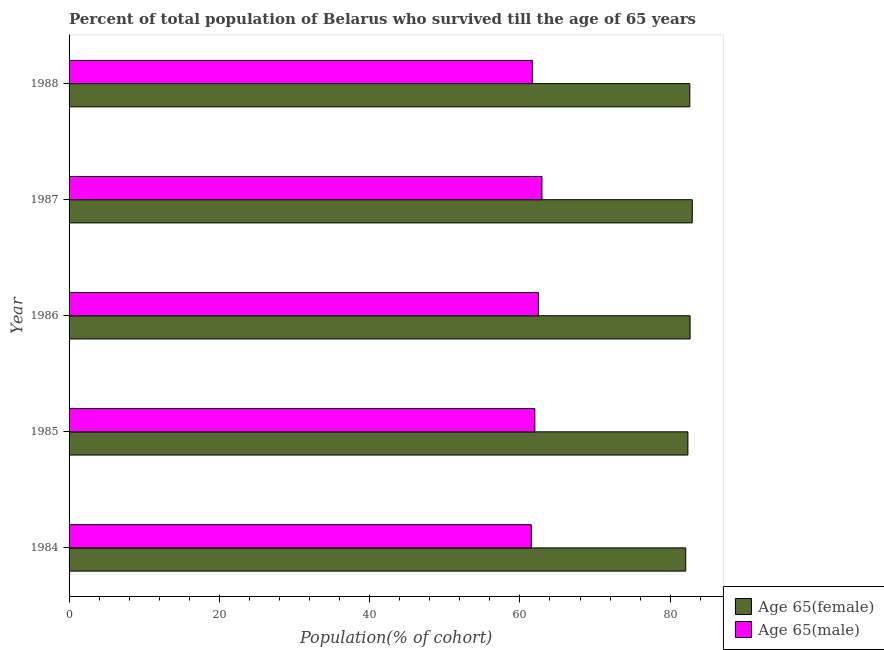How many different coloured bars are there?
Your response must be concise. 2. What is the label of the 4th group of bars from the top?
Ensure brevity in your answer.  1985. In how many cases, is the number of bars for a given year not equal to the number of legend labels?
Your answer should be compact. 0. What is the percentage of female population who survived till age of 65 in 1986?
Offer a very short reply. 82.65. Across all years, what is the maximum percentage of female population who survived till age of 65?
Your response must be concise. 82.94. Across all years, what is the minimum percentage of male population who survived till age of 65?
Your response must be concise. 61.52. In which year was the percentage of female population who survived till age of 65 minimum?
Make the answer very short. 1984. What is the total percentage of male population who survived till age of 65 in the graph?
Offer a very short reply. 310.56. What is the difference between the percentage of male population who survived till age of 65 in 1984 and that in 1987?
Give a very brief answer. -1.41. What is the difference between the percentage of female population who survived till age of 65 in 1985 and the percentage of male population who survived till age of 65 in 1988?
Keep it short and to the point. 20.7. What is the average percentage of female population who survived till age of 65 per year?
Ensure brevity in your answer.  82.53. In the year 1988, what is the difference between the percentage of male population who survived till age of 65 and percentage of female population who survived till age of 65?
Make the answer very short. -20.96. In how many years, is the percentage of male population who survived till age of 65 greater than 32 %?
Provide a succinct answer. 5. Is the percentage of female population who survived till age of 65 in 1984 less than that in 1988?
Give a very brief answer. Yes. What is the difference between the highest and the second highest percentage of male population who survived till age of 65?
Your response must be concise. 0.47. What is the difference between the highest and the lowest percentage of male population who survived till age of 65?
Make the answer very short. 1.41. What does the 1st bar from the top in 1985 represents?
Ensure brevity in your answer.  Age 65(male). What does the 2nd bar from the bottom in 1987 represents?
Keep it short and to the point. Age 65(male). How many bars are there?
Make the answer very short. 10. How many years are there in the graph?
Your response must be concise. 5. What is the difference between two consecutive major ticks on the X-axis?
Provide a short and direct response. 20. Are the values on the major ticks of X-axis written in scientific E-notation?
Give a very brief answer. No. Does the graph contain any zero values?
Provide a short and direct response. No. Does the graph contain grids?
Make the answer very short. No. Where does the legend appear in the graph?
Provide a succinct answer. Bottom right. How are the legend labels stacked?
Make the answer very short. Vertical. What is the title of the graph?
Your answer should be very brief. Percent of total population of Belarus who survived till the age of 65 years. What is the label or title of the X-axis?
Your answer should be compact. Population(% of cohort). What is the label or title of the Y-axis?
Ensure brevity in your answer.  Year. What is the Population(% of cohort) of Age 65(female) in 1984?
Offer a very short reply. 82.07. What is the Population(% of cohort) in Age 65(male) in 1984?
Keep it short and to the point. 61.52. What is the Population(% of cohort) in Age 65(female) in 1985?
Provide a short and direct response. 82.36. What is the Population(% of cohort) of Age 65(male) in 1985?
Your answer should be very brief. 61.99. What is the Population(% of cohort) of Age 65(female) in 1986?
Your response must be concise. 82.65. What is the Population(% of cohort) of Age 65(male) in 1986?
Provide a succinct answer. 62.46. What is the Population(% of cohort) of Age 65(female) in 1987?
Give a very brief answer. 82.94. What is the Population(% of cohort) of Age 65(male) in 1987?
Provide a short and direct response. 62.93. What is the Population(% of cohort) in Age 65(female) in 1988?
Make the answer very short. 82.62. What is the Population(% of cohort) in Age 65(male) in 1988?
Provide a short and direct response. 61.66. Across all years, what is the maximum Population(% of cohort) of Age 65(female)?
Keep it short and to the point. 82.94. Across all years, what is the maximum Population(% of cohort) of Age 65(male)?
Your response must be concise. 62.93. Across all years, what is the minimum Population(% of cohort) of Age 65(female)?
Your response must be concise. 82.07. Across all years, what is the minimum Population(% of cohort) in Age 65(male)?
Your response must be concise. 61.52. What is the total Population(% of cohort) of Age 65(female) in the graph?
Your answer should be compact. 412.64. What is the total Population(% of cohort) of Age 65(male) in the graph?
Offer a very short reply. 310.56. What is the difference between the Population(% of cohort) of Age 65(female) in 1984 and that in 1985?
Offer a terse response. -0.29. What is the difference between the Population(% of cohort) in Age 65(male) in 1984 and that in 1985?
Offer a terse response. -0.47. What is the difference between the Population(% of cohort) in Age 65(female) in 1984 and that in 1986?
Ensure brevity in your answer.  -0.58. What is the difference between the Population(% of cohort) of Age 65(male) in 1984 and that in 1986?
Offer a very short reply. -0.94. What is the difference between the Population(% of cohort) in Age 65(female) in 1984 and that in 1987?
Your answer should be very brief. -0.87. What is the difference between the Population(% of cohort) of Age 65(male) in 1984 and that in 1987?
Make the answer very short. -1.41. What is the difference between the Population(% of cohort) of Age 65(female) in 1984 and that in 1988?
Keep it short and to the point. -0.54. What is the difference between the Population(% of cohort) in Age 65(male) in 1984 and that in 1988?
Your answer should be very brief. -0.14. What is the difference between the Population(% of cohort) of Age 65(female) in 1985 and that in 1986?
Keep it short and to the point. -0.29. What is the difference between the Population(% of cohort) in Age 65(male) in 1985 and that in 1986?
Your answer should be very brief. -0.47. What is the difference between the Population(% of cohort) in Age 65(female) in 1985 and that in 1987?
Keep it short and to the point. -0.58. What is the difference between the Population(% of cohort) in Age 65(male) in 1985 and that in 1987?
Your answer should be very brief. -0.94. What is the difference between the Population(% of cohort) of Age 65(female) in 1985 and that in 1988?
Provide a succinct answer. -0.25. What is the difference between the Population(% of cohort) in Age 65(male) in 1985 and that in 1988?
Offer a very short reply. 0.33. What is the difference between the Population(% of cohort) in Age 65(female) in 1986 and that in 1987?
Provide a short and direct response. -0.29. What is the difference between the Population(% of cohort) in Age 65(male) in 1986 and that in 1987?
Your answer should be compact. -0.47. What is the difference between the Population(% of cohort) in Age 65(female) in 1986 and that in 1988?
Provide a short and direct response. 0.04. What is the difference between the Population(% of cohort) in Age 65(male) in 1986 and that in 1988?
Ensure brevity in your answer.  0.8. What is the difference between the Population(% of cohort) of Age 65(female) in 1987 and that in 1988?
Provide a short and direct response. 0.33. What is the difference between the Population(% of cohort) in Age 65(male) in 1987 and that in 1988?
Give a very brief answer. 1.27. What is the difference between the Population(% of cohort) of Age 65(female) in 1984 and the Population(% of cohort) of Age 65(male) in 1985?
Your answer should be very brief. 20.08. What is the difference between the Population(% of cohort) of Age 65(female) in 1984 and the Population(% of cohort) of Age 65(male) in 1986?
Your response must be concise. 19.61. What is the difference between the Population(% of cohort) of Age 65(female) in 1984 and the Population(% of cohort) of Age 65(male) in 1987?
Offer a very short reply. 19.14. What is the difference between the Population(% of cohort) of Age 65(female) in 1984 and the Population(% of cohort) of Age 65(male) in 1988?
Your response must be concise. 20.41. What is the difference between the Population(% of cohort) of Age 65(female) in 1985 and the Population(% of cohort) of Age 65(male) in 1986?
Provide a short and direct response. 19.9. What is the difference between the Population(% of cohort) in Age 65(female) in 1985 and the Population(% of cohort) in Age 65(male) in 1987?
Keep it short and to the point. 19.43. What is the difference between the Population(% of cohort) in Age 65(female) in 1985 and the Population(% of cohort) in Age 65(male) in 1988?
Your answer should be very brief. 20.7. What is the difference between the Population(% of cohort) in Age 65(female) in 1986 and the Population(% of cohort) in Age 65(male) in 1987?
Your answer should be compact. 19.72. What is the difference between the Population(% of cohort) in Age 65(female) in 1986 and the Population(% of cohort) in Age 65(male) in 1988?
Provide a short and direct response. 20.99. What is the difference between the Population(% of cohort) in Age 65(female) in 1987 and the Population(% of cohort) in Age 65(male) in 1988?
Ensure brevity in your answer.  21.28. What is the average Population(% of cohort) in Age 65(female) per year?
Your answer should be compact. 82.53. What is the average Population(% of cohort) in Age 65(male) per year?
Offer a very short reply. 62.11. In the year 1984, what is the difference between the Population(% of cohort) of Age 65(female) and Population(% of cohort) of Age 65(male)?
Ensure brevity in your answer.  20.55. In the year 1985, what is the difference between the Population(% of cohort) in Age 65(female) and Population(% of cohort) in Age 65(male)?
Provide a succinct answer. 20.37. In the year 1986, what is the difference between the Population(% of cohort) in Age 65(female) and Population(% of cohort) in Age 65(male)?
Provide a succinct answer. 20.19. In the year 1987, what is the difference between the Population(% of cohort) of Age 65(female) and Population(% of cohort) of Age 65(male)?
Ensure brevity in your answer.  20.01. In the year 1988, what is the difference between the Population(% of cohort) in Age 65(female) and Population(% of cohort) in Age 65(male)?
Offer a terse response. 20.96. What is the ratio of the Population(% of cohort) in Age 65(male) in 1984 to that in 1985?
Your answer should be very brief. 0.99. What is the ratio of the Population(% of cohort) in Age 65(male) in 1984 to that in 1986?
Keep it short and to the point. 0.98. What is the ratio of the Population(% of cohort) in Age 65(female) in 1984 to that in 1987?
Offer a terse response. 0.99. What is the ratio of the Population(% of cohort) of Age 65(male) in 1984 to that in 1987?
Give a very brief answer. 0.98. What is the ratio of the Population(% of cohort) in Age 65(female) in 1984 to that in 1988?
Make the answer very short. 0.99. What is the ratio of the Population(% of cohort) in Age 65(male) in 1984 to that in 1988?
Offer a terse response. 1. What is the ratio of the Population(% of cohort) in Age 65(male) in 1985 to that in 1987?
Keep it short and to the point. 0.99. What is the ratio of the Population(% of cohort) in Age 65(male) in 1985 to that in 1988?
Provide a short and direct response. 1.01. What is the ratio of the Population(% of cohort) of Age 65(male) in 1986 to that in 1987?
Make the answer very short. 0.99. What is the ratio of the Population(% of cohort) in Age 65(female) in 1986 to that in 1988?
Provide a short and direct response. 1. What is the ratio of the Population(% of cohort) of Age 65(female) in 1987 to that in 1988?
Make the answer very short. 1. What is the ratio of the Population(% of cohort) in Age 65(male) in 1987 to that in 1988?
Give a very brief answer. 1.02. What is the difference between the highest and the second highest Population(% of cohort) in Age 65(female)?
Your answer should be very brief. 0.29. What is the difference between the highest and the second highest Population(% of cohort) of Age 65(male)?
Keep it short and to the point. 0.47. What is the difference between the highest and the lowest Population(% of cohort) in Age 65(female)?
Your answer should be compact. 0.87. What is the difference between the highest and the lowest Population(% of cohort) in Age 65(male)?
Your answer should be compact. 1.41. 